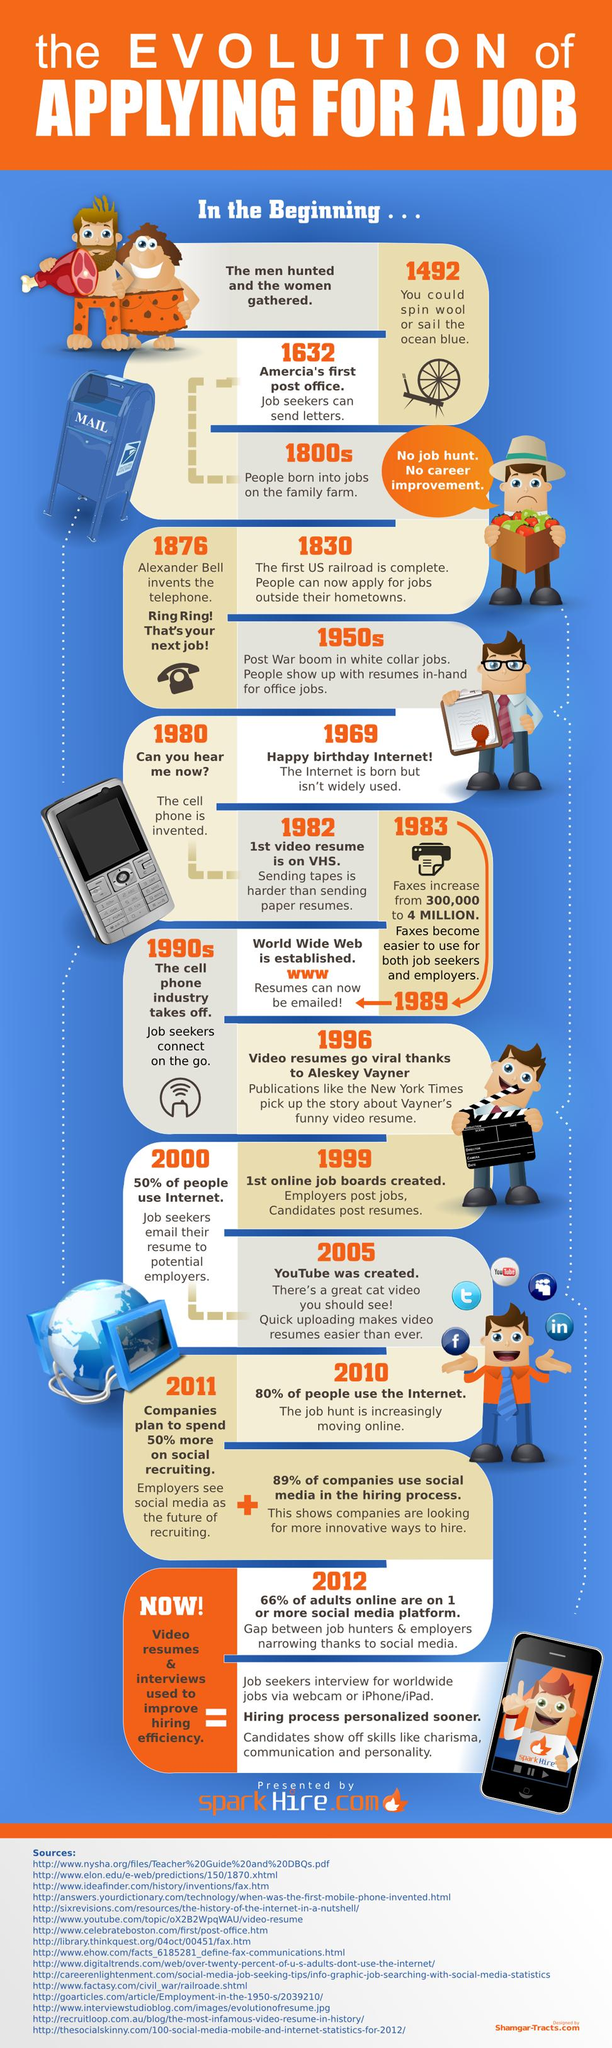Indicate a few pertinent items in this graphic. Thirty-six years have passed since the internet was created, and YouTube was created three years later. In 2000, approximately 50% of the population did not use the internet. The invention of the telephone by Alexander Bell occurred 93 years before the birth of the internet. The America's first post office was built 244 years before Alexander Bell invented the telephone. 